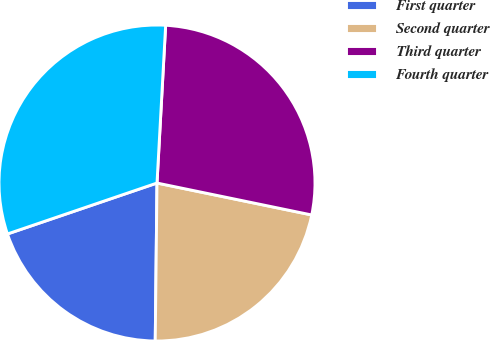Convert chart to OTSL. <chart><loc_0><loc_0><loc_500><loc_500><pie_chart><fcel>First quarter<fcel>Second quarter<fcel>Third quarter<fcel>Fourth quarter<nl><fcel>19.6%<fcel>21.94%<fcel>27.37%<fcel>31.1%<nl></chart> 